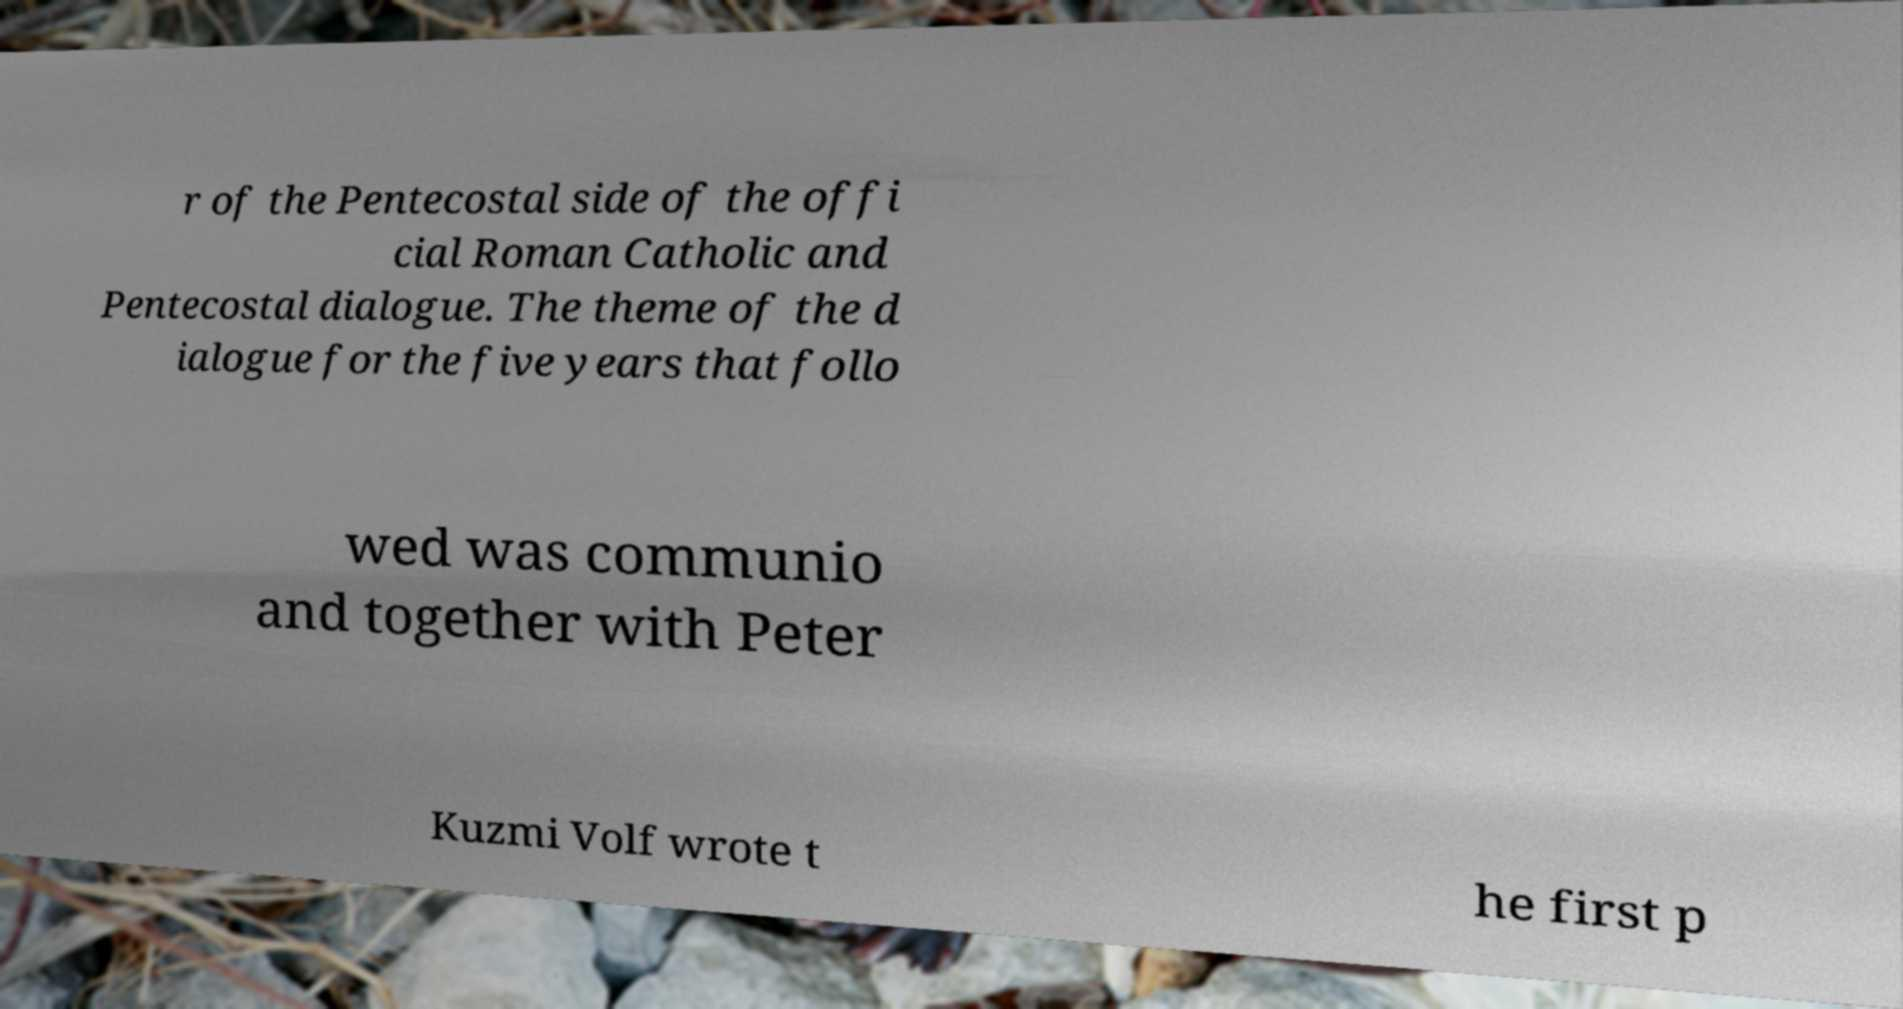There's text embedded in this image that I need extracted. Can you transcribe it verbatim? r of the Pentecostal side of the offi cial Roman Catholic and Pentecostal dialogue. The theme of the d ialogue for the five years that follo wed was communio and together with Peter Kuzmi Volf wrote t he first p 